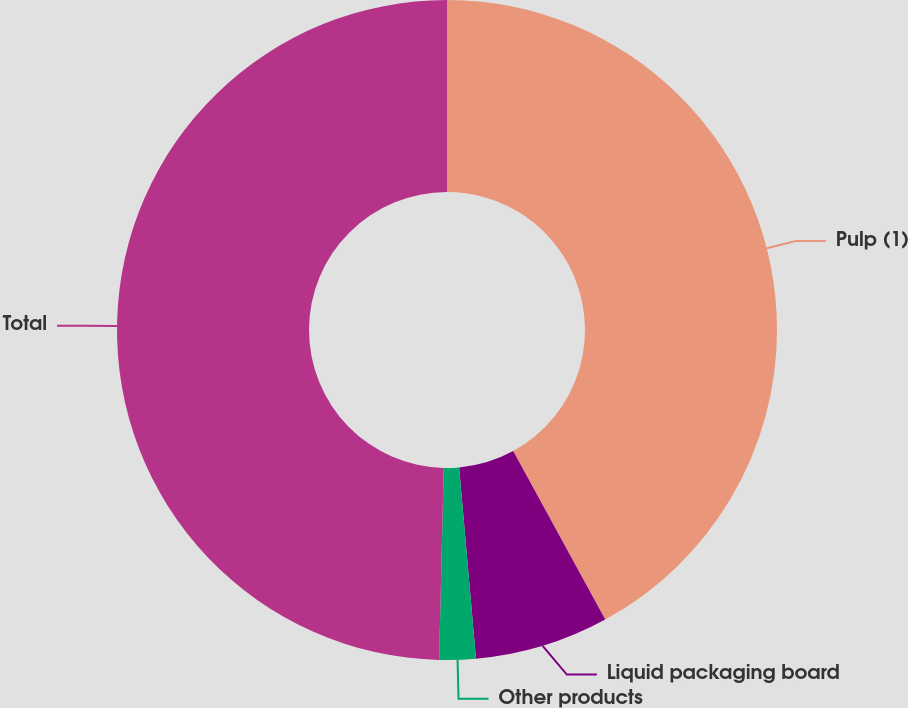<chart> <loc_0><loc_0><loc_500><loc_500><pie_chart><fcel>Pulp (1)<fcel>Liquid packaging board<fcel>Other products<fcel>Total<nl><fcel>42.04%<fcel>6.56%<fcel>1.78%<fcel>49.62%<nl></chart> 